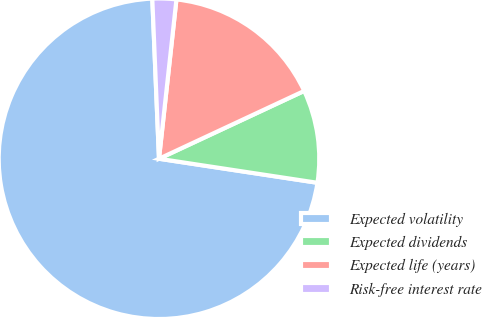<chart> <loc_0><loc_0><loc_500><loc_500><pie_chart><fcel>Expected volatility<fcel>Expected dividends<fcel>Expected life (years)<fcel>Risk-free interest rate<nl><fcel>71.94%<fcel>9.35%<fcel>16.31%<fcel>2.4%<nl></chart> 